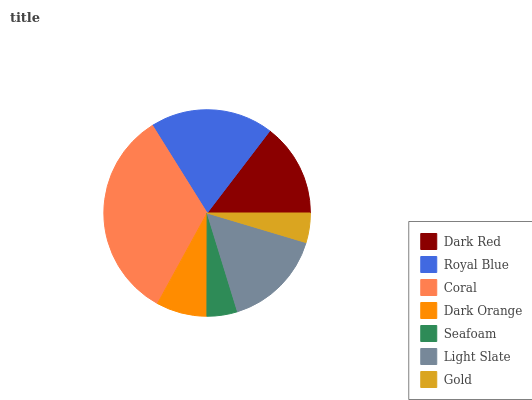Is Gold the minimum?
Answer yes or no. Yes. Is Coral the maximum?
Answer yes or no. Yes. Is Royal Blue the minimum?
Answer yes or no. No. Is Royal Blue the maximum?
Answer yes or no. No. Is Royal Blue greater than Dark Red?
Answer yes or no. Yes. Is Dark Red less than Royal Blue?
Answer yes or no. Yes. Is Dark Red greater than Royal Blue?
Answer yes or no. No. Is Royal Blue less than Dark Red?
Answer yes or no. No. Is Dark Red the high median?
Answer yes or no. Yes. Is Dark Red the low median?
Answer yes or no. Yes. Is Gold the high median?
Answer yes or no. No. Is Gold the low median?
Answer yes or no. No. 